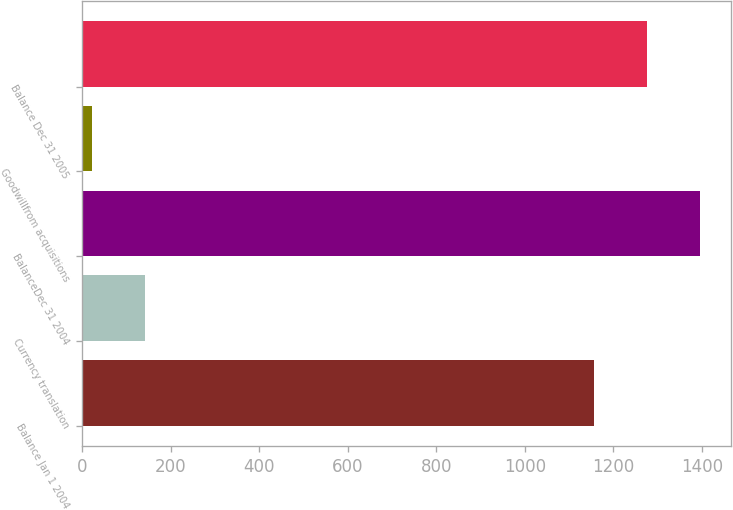<chart> <loc_0><loc_0><loc_500><loc_500><bar_chart><fcel>Balance Jan 1 2004<fcel>Currency translation<fcel>BalanceDec 31 2004<fcel>Goodwillfrom acquisitions<fcel>Balance Dec 31 2005<nl><fcel>1157<fcel>140.5<fcel>1396<fcel>21<fcel>1276.5<nl></chart> 